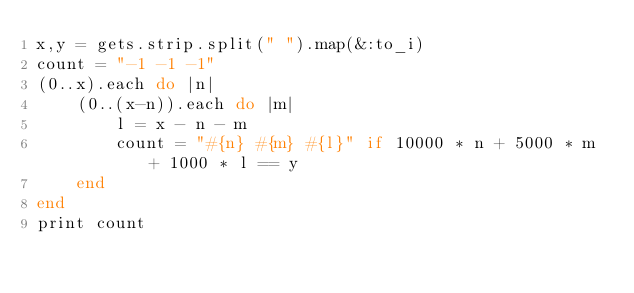Convert code to text. <code><loc_0><loc_0><loc_500><loc_500><_Ruby_>x,y = gets.strip.split(" ").map(&:to_i)
count = "-1 -1 -1"
(0..x).each do |n|
    (0..(x-n)).each do |m|
        l = x - n - m
        count = "#{n} #{m} #{l}" if 10000 * n + 5000 * m + 1000 * l == y
    end
end
print count</code> 